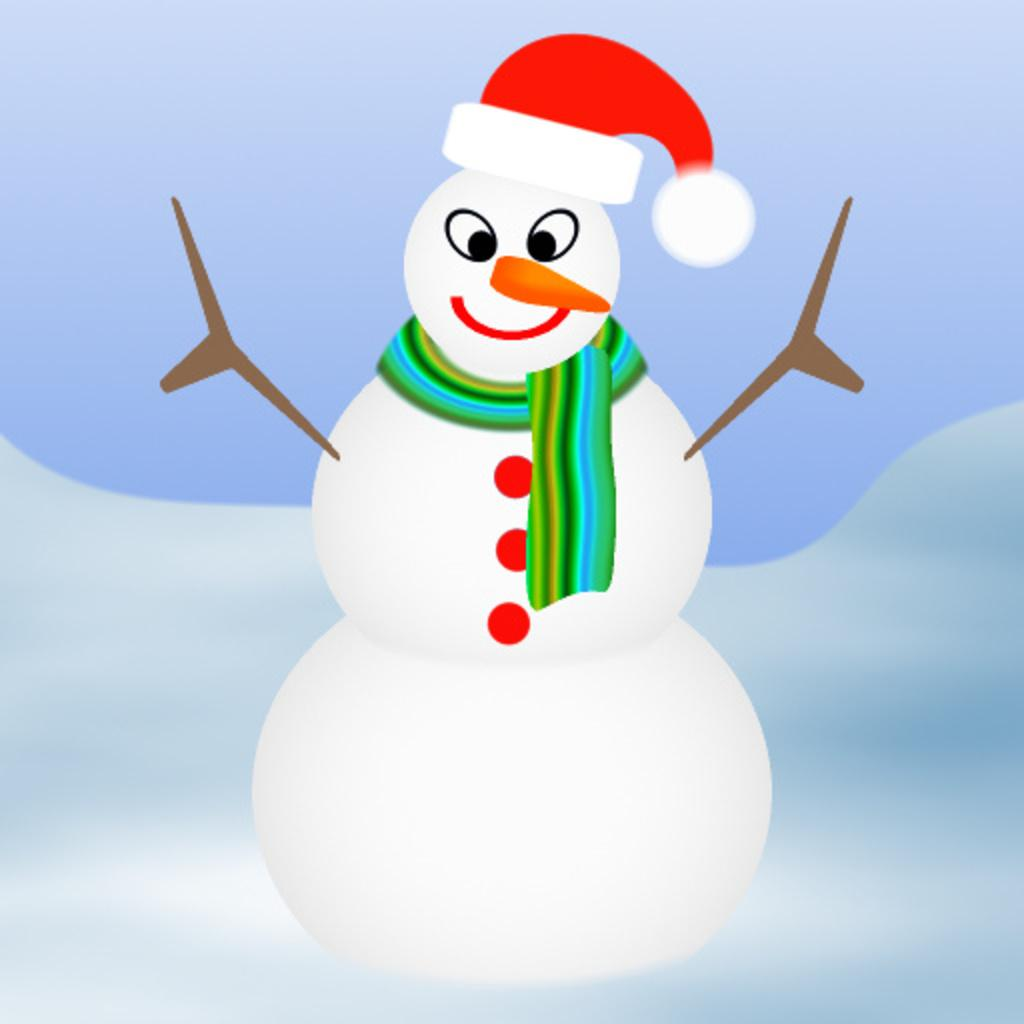What is the main subject of the picture? The main subject of the picture is a snowman. Can you tell me how many times the snowman sneezes in the image? There is no sneezing depicted in the image, as it features a snowman. What type of powder is used to create the snowman in the image? The image does not provide information about the materials used to create the snowman, so it cannot be determined from the picture. 